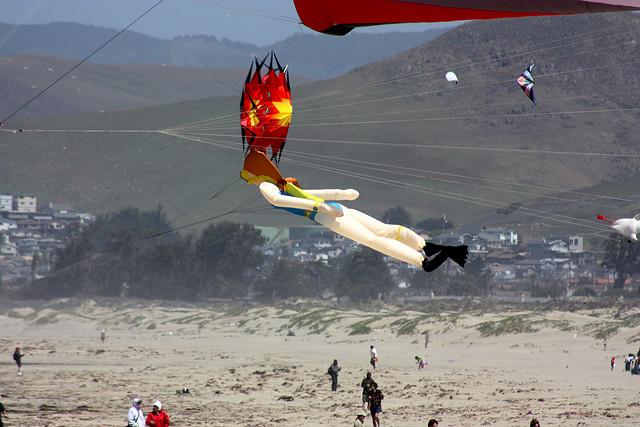Compose a poetic reflection inspired by the image. Upon the silver sands where the ocean meets the sky,
The whispering winds lift hopes so high.
Kites like dreams take flight in colors bright,
Dancing with the breeze in the amber light.
Each string a tether to the earth below,
Yet soaring hearts in the currents flow.
The hills embrace the town in their gentle sweep,
Guardians of secrets that the beach does keep.
In every wave and kite's ascent,
A harmony of nature and joy is blent.
Here, upon this shore, where spirits roam carefree,
The endless horizon shows boundless possibility. 